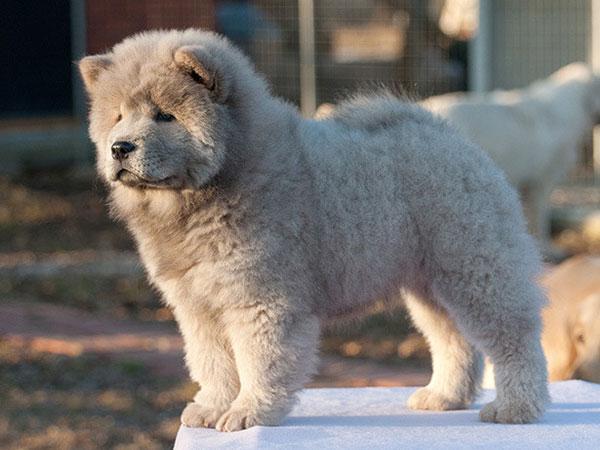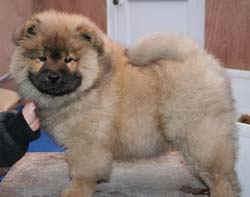The first image is the image on the left, the second image is the image on the right. For the images shown, is this caption "One image features a person behind a chow posed standing on all fours and looking toward the camera." true? Answer yes or no. No. The first image is the image on the left, the second image is the image on the right. Given the left and right images, does the statement "There are two dogs standing on four legs." hold true? Answer yes or no. Yes. 